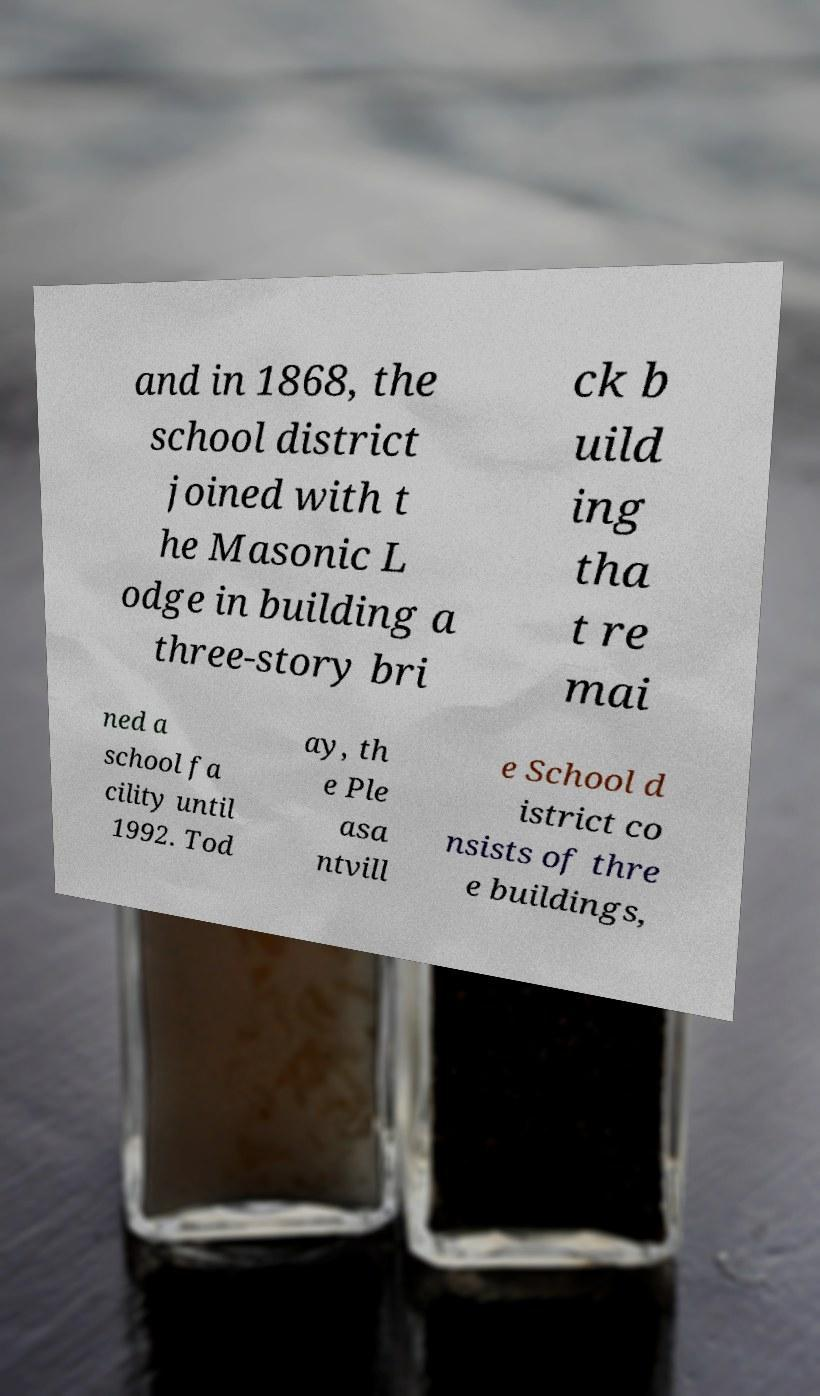For documentation purposes, I need the text within this image transcribed. Could you provide that? and in 1868, the school district joined with t he Masonic L odge in building a three-story bri ck b uild ing tha t re mai ned a school fa cility until 1992. Tod ay, th e Ple asa ntvill e School d istrict co nsists of thre e buildings, 